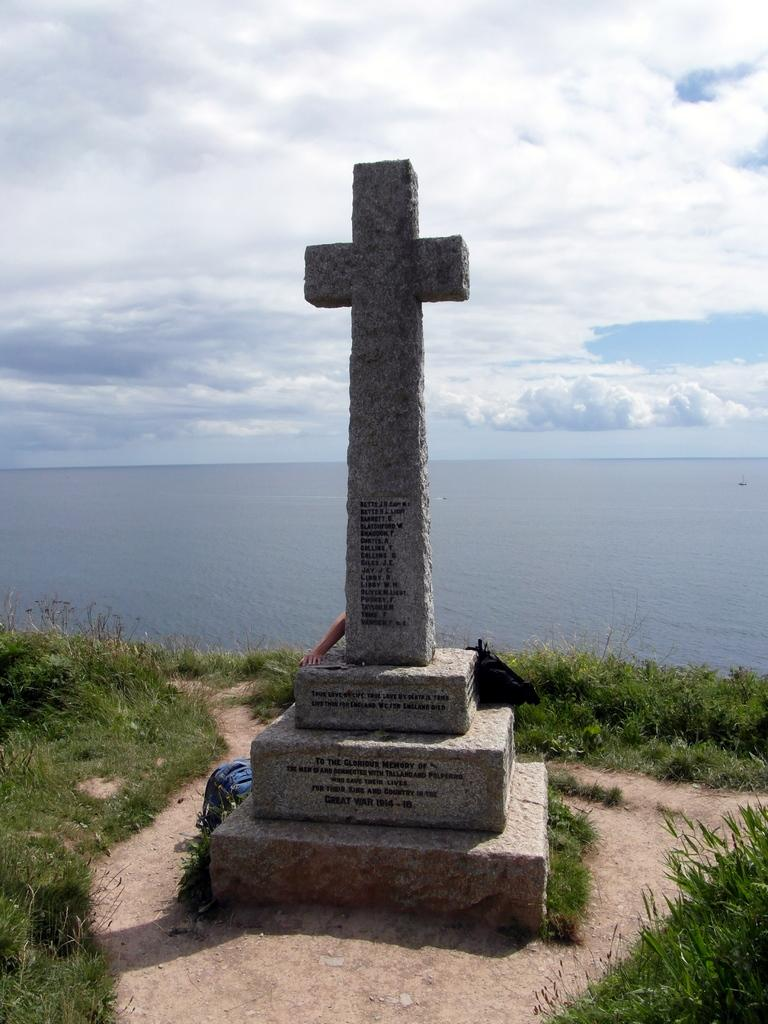What religious symbol can be seen in the picture? There is a cross in the picture. Who is present in the picture? There is a man in the picture. What object is the man carrying? There is a bag in the picture. What type of terrain is visible in the picture? There is grass in the picture. What can be seen in the distance in the background of the picture? There is a sea in the background of the picture. How would you describe the weather based on the image? The sky is clear in the picture. Can you tell me how many parents are visible in the picture? There are no parents present in the picture; it only features a man and a cross. What type of building can be seen in the background of the picture? There is no building visible in the background of the picture; it features a sea instead. 